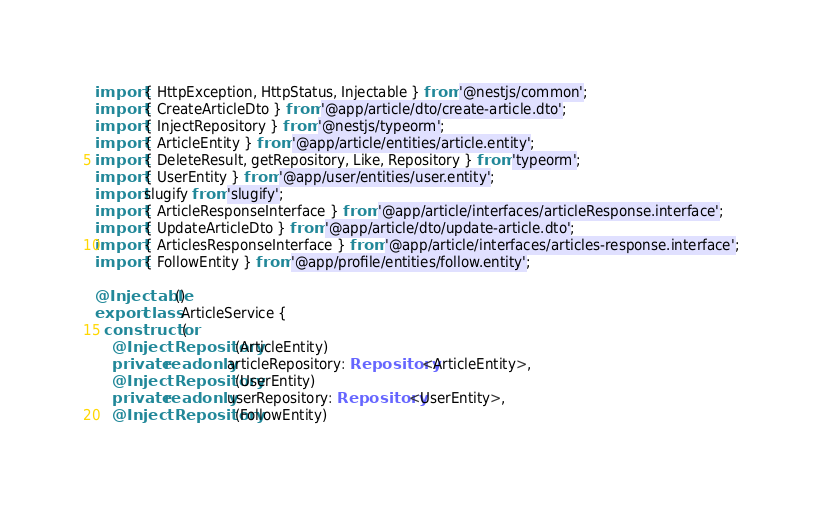Convert code to text. <code><loc_0><loc_0><loc_500><loc_500><_TypeScript_>import { HttpException, HttpStatus, Injectable } from '@nestjs/common';
import { CreateArticleDto } from '@app/article/dto/create-article.dto';
import { InjectRepository } from '@nestjs/typeorm';
import { ArticleEntity } from '@app/article/entities/article.entity';
import { DeleteResult, getRepository, Like, Repository } from 'typeorm';
import { UserEntity } from '@app/user/entities/user.entity';
import slugify from 'slugify';
import { ArticleResponseInterface } from '@app/article/interfaces/articleResponse.interface';
import { UpdateArticleDto } from '@app/article/dto/update-article.dto';
import { ArticlesResponseInterface } from '@app/article/interfaces/articles-response.interface';
import { FollowEntity } from '@app/profile/entities/follow.entity';

@Injectable()
export class ArticleService {
  constructor(
    @InjectRepository(ArticleEntity)
    private readonly articleRepository: Repository<ArticleEntity>,
    @InjectRepository(UserEntity)
    private readonly userRepository: Repository<UserEntity>,
    @InjectRepository(FollowEntity)</code> 